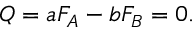<formula> <loc_0><loc_0><loc_500><loc_500>Q = a F _ { A } - b F _ { B } = 0 .</formula> 